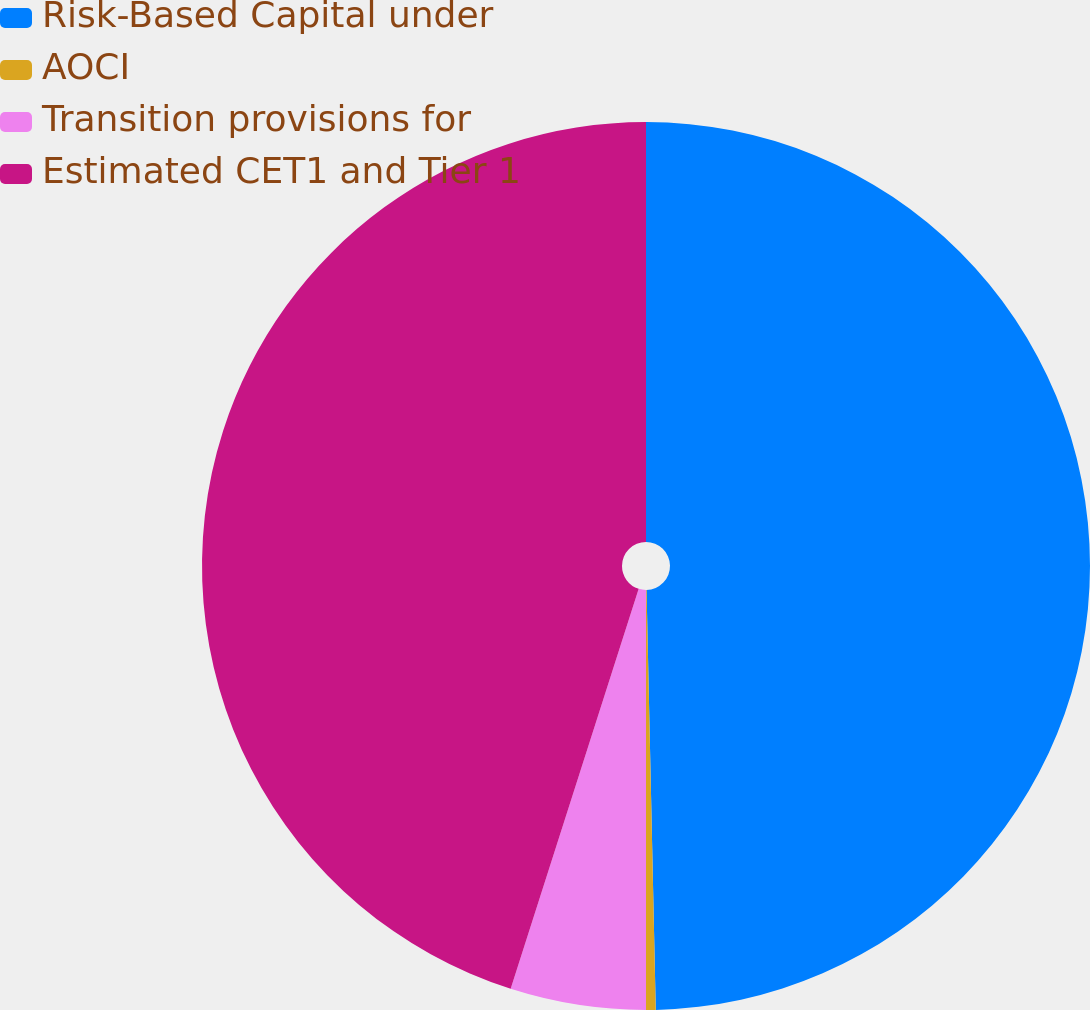Convert chart to OTSL. <chart><loc_0><loc_0><loc_500><loc_500><pie_chart><fcel>Risk-Based Capital under<fcel>AOCI<fcel>Transition provisions for<fcel>Estimated CET1 and Tier 1<nl><fcel>49.65%<fcel>0.35%<fcel>4.93%<fcel>45.07%<nl></chart> 